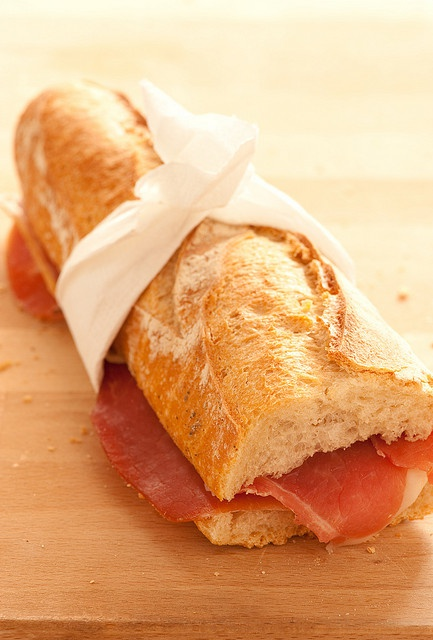Describe the objects in this image and their specific colors. I can see a sandwich in beige, orange, red, and tan tones in this image. 